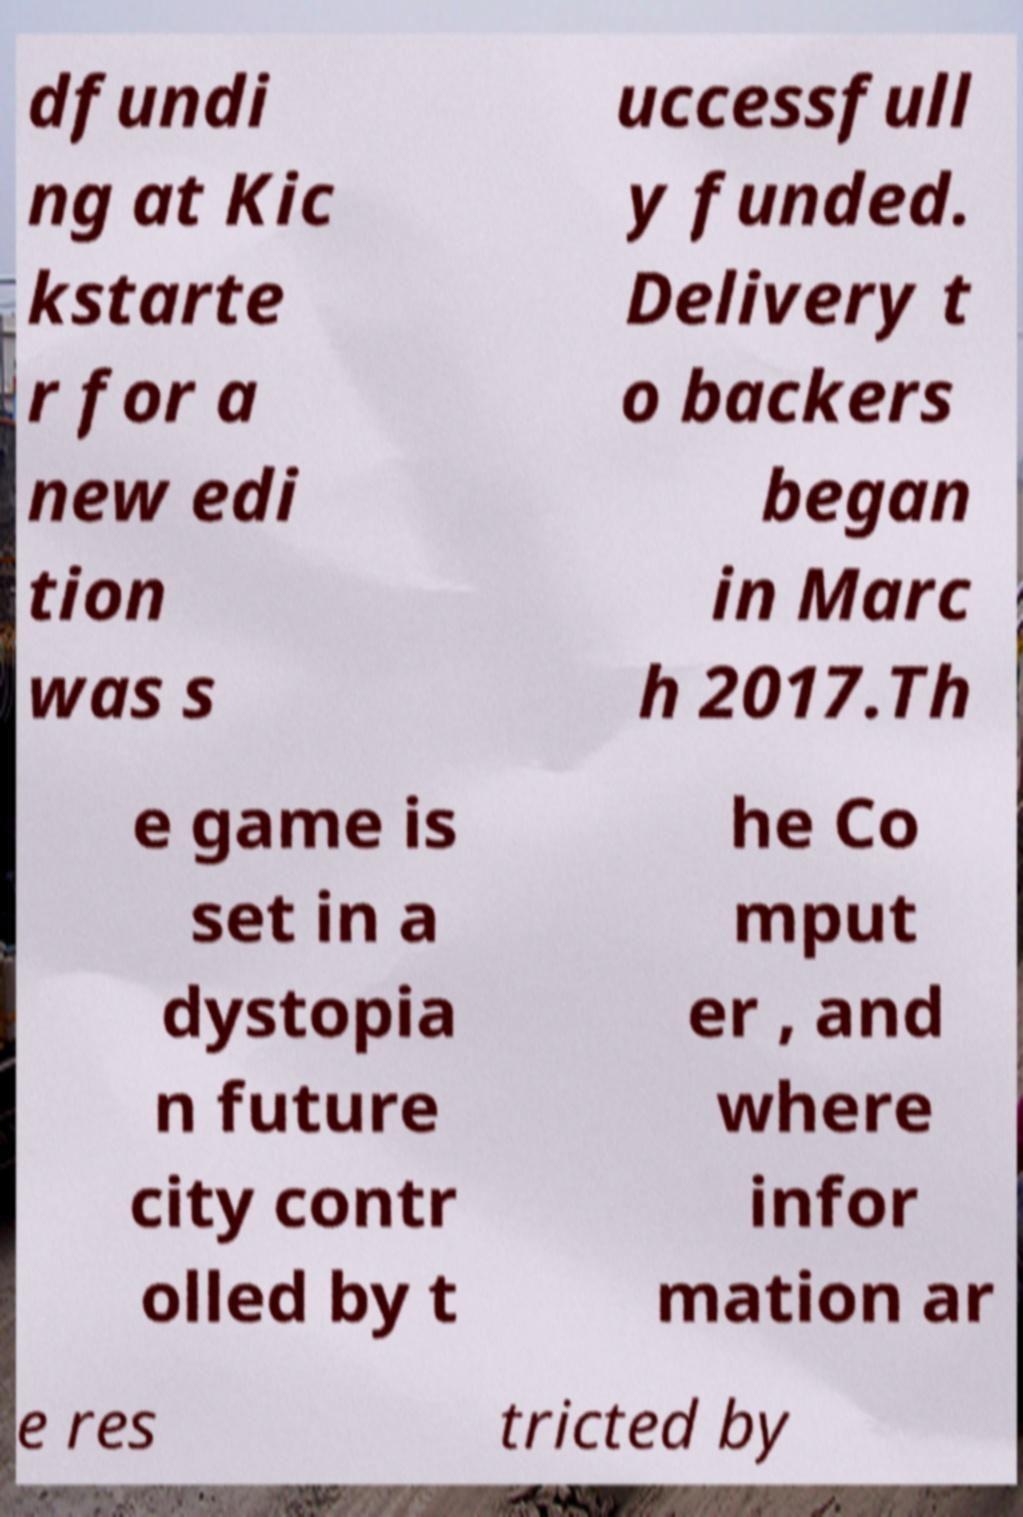Can you accurately transcribe the text from the provided image for me? dfundi ng at Kic kstarte r for a new edi tion was s uccessfull y funded. Delivery t o backers began in Marc h 2017.Th e game is set in a dystopia n future city contr olled by t he Co mput er , and where infor mation ar e res tricted by 